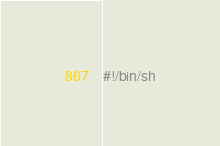Convert code to text. <code><loc_0><loc_0><loc_500><loc_500><_Bash_>#!/bin/sh
</code> 